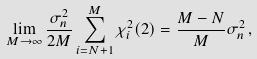Convert formula to latex. <formula><loc_0><loc_0><loc_500><loc_500>\lim _ { M \to \infty } \frac { \sigma _ { n } ^ { 2 } } { 2 M } \sum _ { i = N + 1 } ^ { M } \chi _ { i } ^ { 2 } ( 2 ) = \frac { M - N } { M } \sigma _ { n } ^ { 2 } \, ,</formula> 